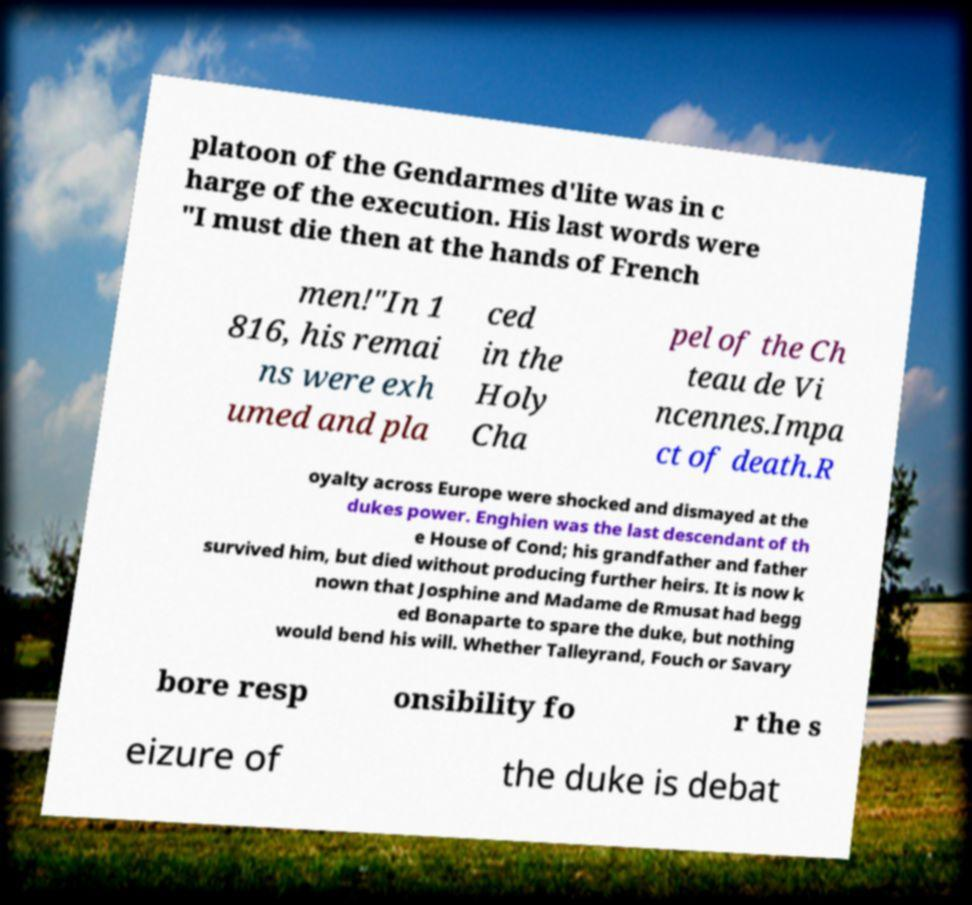Can you accurately transcribe the text from the provided image for me? platoon of the Gendarmes d'lite was in c harge of the execution. His last words were "I must die then at the hands of French men!"In 1 816, his remai ns were exh umed and pla ced in the Holy Cha pel of the Ch teau de Vi ncennes.Impa ct of death.R oyalty across Europe were shocked and dismayed at the dukes power. Enghien was the last descendant of th e House of Cond; his grandfather and father survived him, but died without producing further heirs. It is now k nown that Josphine and Madame de Rmusat had begg ed Bonaparte to spare the duke, but nothing would bend his will. Whether Talleyrand, Fouch or Savary bore resp onsibility fo r the s eizure of the duke is debat 